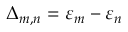<formula> <loc_0><loc_0><loc_500><loc_500>\Delta _ { m , n } = { \varepsilon } _ { m } - { \varepsilon } _ { n }</formula> 